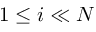Convert formula to latex. <formula><loc_0><loc_0><loc_500><loc_500>1 \leq i \ll N</formula> 